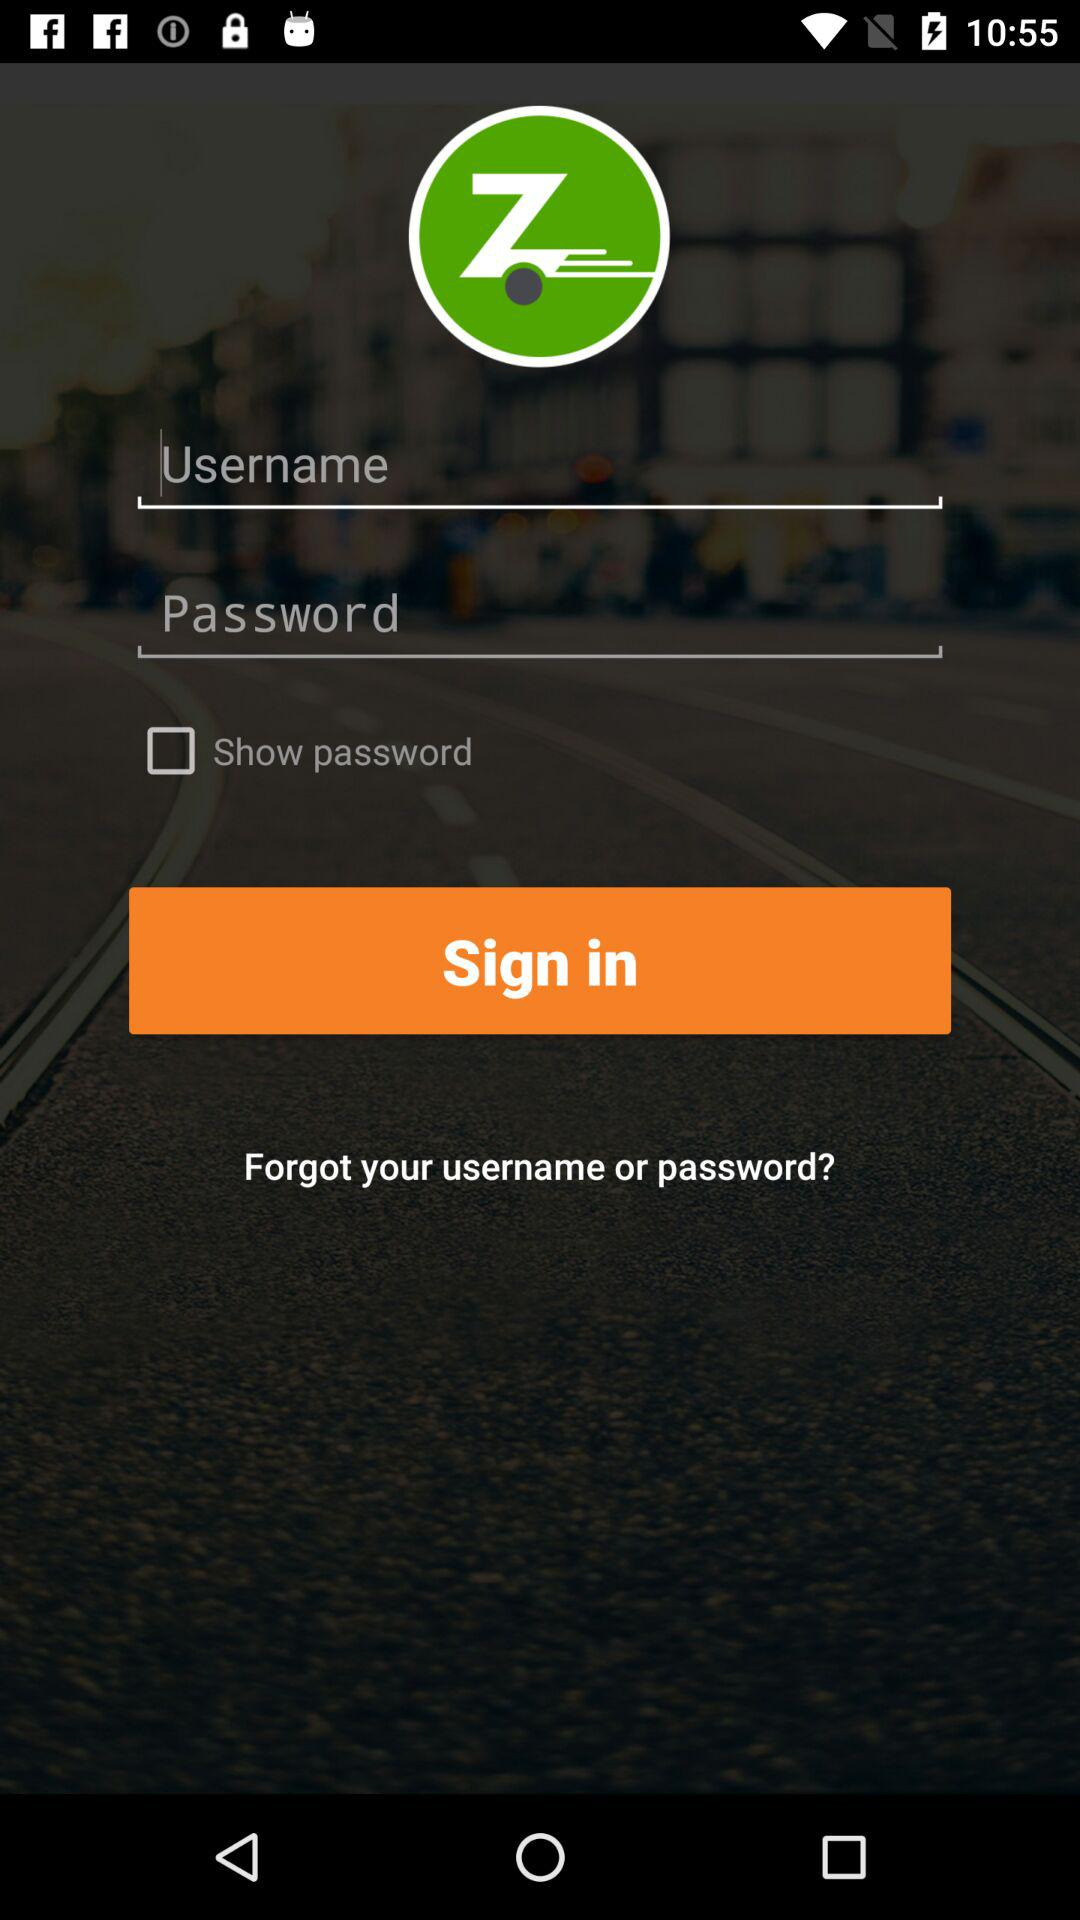What is the status of "Show password"? The status of "Show password" is "off". 